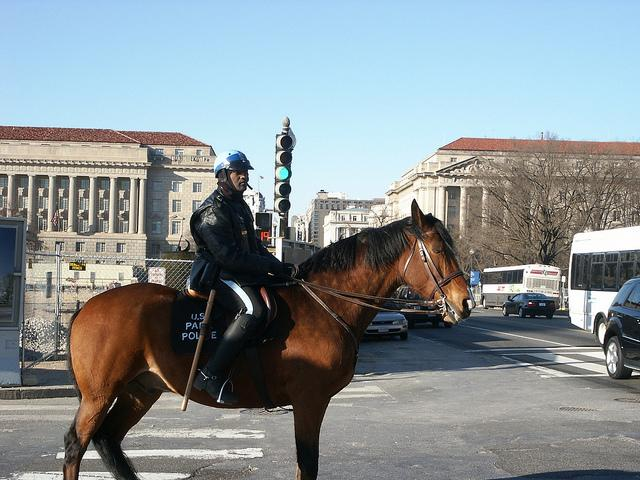Why is he on a horse? patrol 